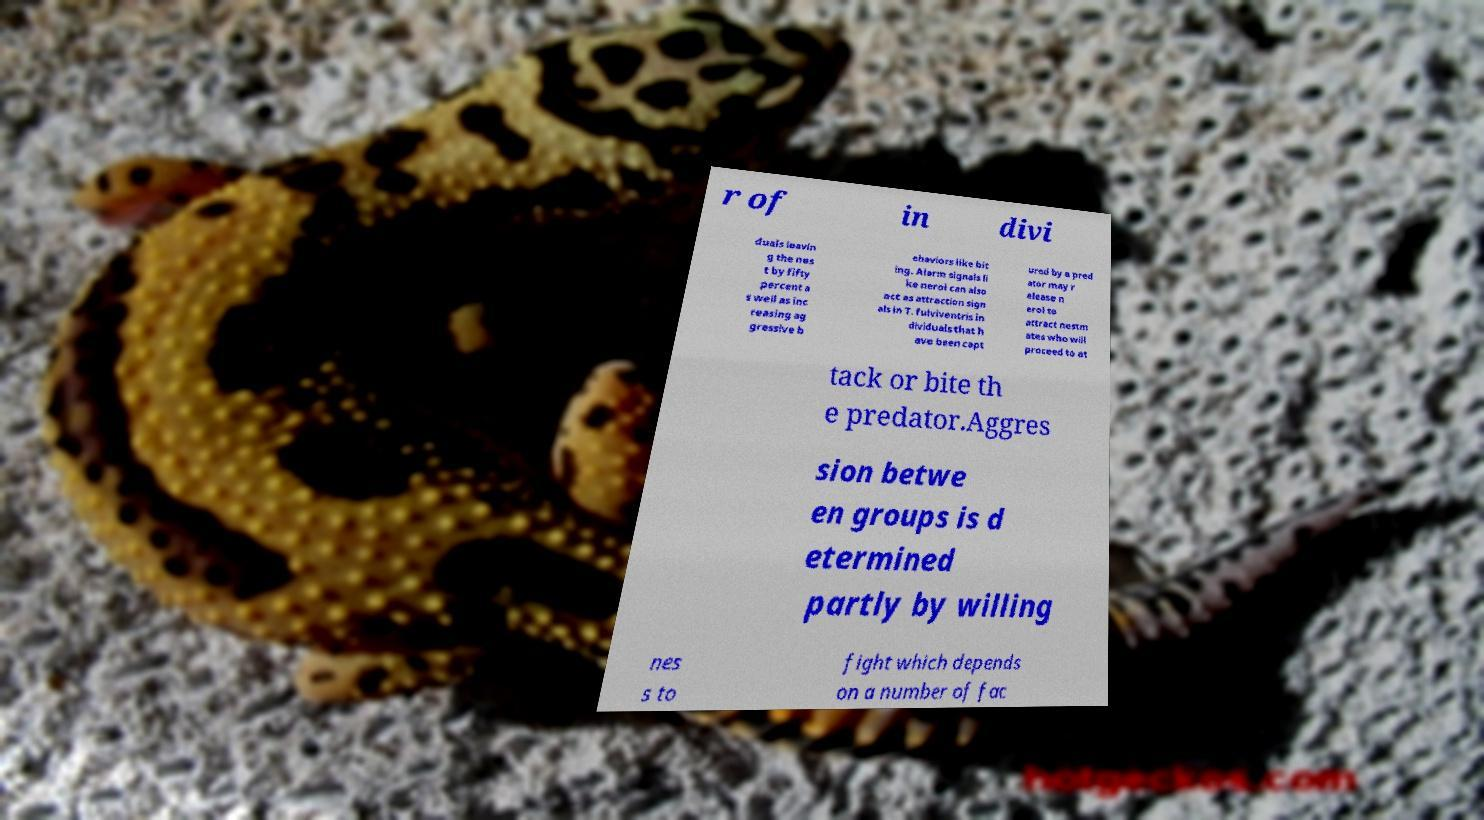Could you extract and type out the text from this image? r of in divi duals leavin g the nes t by fifty percent a s well as inc reasing ag gressive b ehaviors like bit ing. Alarm signals li ke nerol can also act as attraction sign als in T. fulviventris in dividuals that h ave been capt ured by a pred ator may r elease n erol to attract nestm ates who will proceed to at tack or bite th e predator.Aggres sion betwe en groups is d etermined partly by willing nes s to fight which depends on a number of fac 